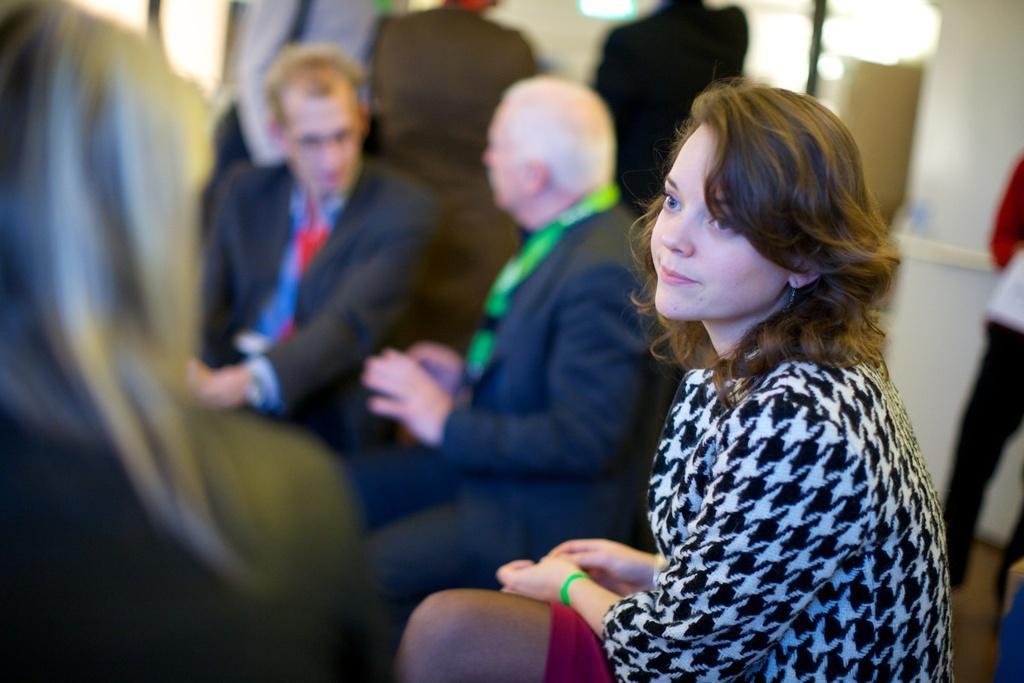Describe this image in one or two sentences. In this image we can see some group of persons sitting, in the foreground of the image there is a woman wearing black and white color dress also sitting and in the background of the image there are some persons standing near the wall. 